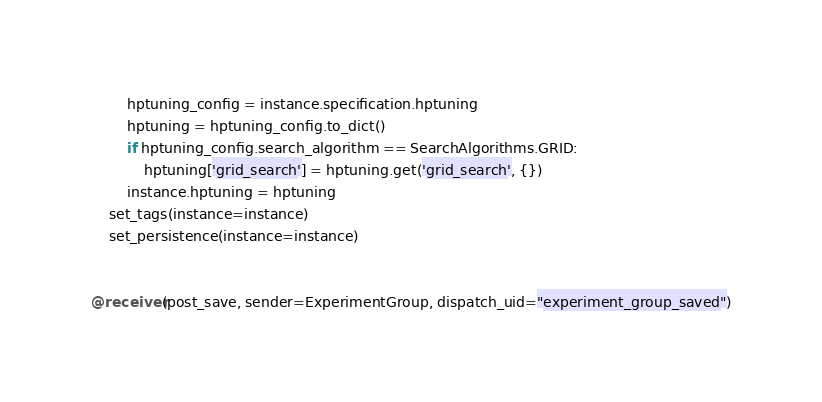Convert code to text. <code><loc_0><loc_0><loc_500><loc_500><_Python_>        hptuning_config = instance.specification.hptuning
        hptuning = hptuning_config.to_dict()
        if hptuning_config.search_algorithm == SearchAlgorithms.GRID:
            hptuning['grid_search'] = hptuning.get('grid_search', {})
        instance.hptuning = hptuning
    set_tags(instance=instance)
    set_persistence(instance=instance)


@receiver(post_save, sender=ExperimentGroup, dispatch_uid="experiment_group_saved")</code> 